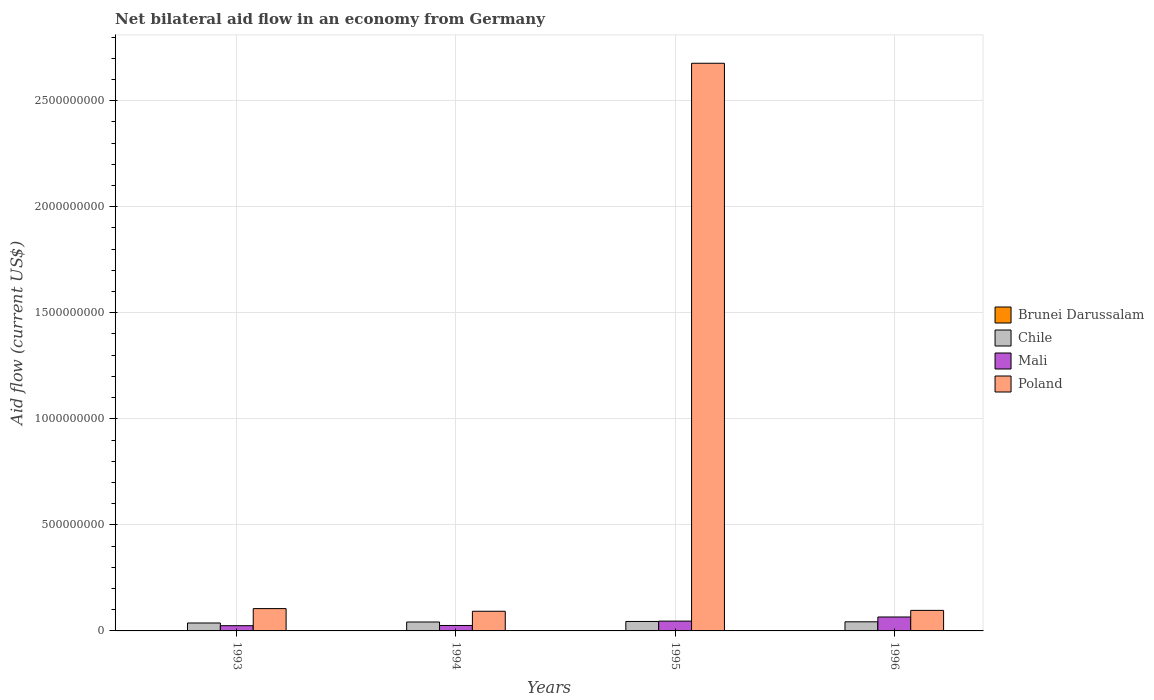How many different coloured bars are there?
Your answer should be compact. 4. How many bars are there on the 2nd tick from the left?
Provide a short and direct response. 4. What is the net bilateral aid flow in Mali in 1995?
Offer a terse response. 4.62e+07. Across all years, what is the maximum net bilateral aid flow in Chile?
Your answer should be very brief. 4.46e+07. Across all years, what is the minimum net bilateral aid flow in Chile?
Offer a terse response. 3.74e+07. What is the total net bilateral aid flow in Brunei Darussalam in the graph?
Make the answer very short. 9.00e+04. What is the difference between the net bilateral aid flow in Poland in 1994 and that in 1996?
Your answer should be very brief. -4.18e+06. What is the difference between the net bilateral aid flow in Poland in 1993 and the net bilateral aid flow in Chile in 1996?
Your answer should be compact. 6.23e+07. What is the average net bilateral aid flow in Mali per year?
Make the answer very short. 4.06e+07. In the year 1996, what is the difference between the net bilateral aid flow in Mali and net bilateral aid flow in Brunei Darussalam?
Make the answer very short. 6.57e+07. What is the ratio of the net bilateral aid flow in Chile in 1994 to that in 1995?
Keep it short and to the point. 0.94. Is the net bilateral aid flow in Poland in 1994 less than that in 1995?
Your answer should be compact. Yes. Is the difference between the net bilateral aid flow in Mali in 1993 and 1996 greater than the difference between the net bilateral aid flow in Brunei Darussalam in 1993 and 1996?
Give a very brief answer. No. What is the difference between the highest and the second highest net bilateral aid flow in Mali?
Give a very brief answer. 1.95e+07. What is the difference between the highest and the lowest net bilateral aid flow in Chile?
Your answer should be very brief. 7.19e+06. In how many years, is the net bilateral aid flow in Chile greater than the average net bilateral aid flow in Chile taken over all years?
Your answer should be compact. 3. Is it the case that in every year, the sum of the net bilateral aid flow in Brunei Darussalam and net bilateral aid flow in Poland is greater than the sum of net bilateral aid flow in Chile and net bilateral aid flow in Mali?
Make the answer very short. Yes. What does the 3rd bar from the left in 1996 represents?
Give a very brief answer. Mali. What does the 2nd bar from the right in 1995 represents?
Offer a terse response. Mali. Is it the case that in every year, the sum of the net bilateral aid flow in Poland and net bilateral aid flow in Mali is greater than the net bilateral aid flow in Brunei Darussalam?
Provide a succinct answer. Yes. Are all the bars in the graph horizontal?
Provide a short and direct response. No. What is the difference between two consecutive major ticks on the Y-axis?
Your response must be concise. 5.00e+08. How many legend labels are there?
Provide a short and direct response. 4. How are the legend labels stacked?
Provide a succinct answer. Vertical. What is the title of the graph?
Your answer should be very brief. Net bilateral aid flow in an economy from Germany. Does "Nicaragua" appear as one of the legend labels in the graph?
Your answer should be very brief. No. What is the label or title of the Y-axis?
Provide a short and direct response. Aid flow (current US$). What is the Aid flow (current US$) in Chile in 1993?
Provide a succinct answer. 3.74e+07. What is the Aid flow (current US$) in Mali in 1993?
Give a very brief answer. 2.46e+07. What is the Aid flow (current US$) in Poland in 1993?
Keep it short and to the point. 1.05e+08. What is the Aid flow (current US$) of Chile in 1994?
Make the answer very short. 4.21e+07. What is the Aid flow (current US$) in Mali in 1994?
Give a very brief answer. 2.57e+07. What is the Aid flow (current US$) in Poland in 1994?
Give a very brief answer. 9.27e+07. What is the Aid flow (current US$) of Brunei Darussalam in 1995?
Your answer should be very brief. 3.00e+04. What is the Aid flow (current US$) of Chile in 1995?
Offer a terse response. 4.46e+07. What is the Aid flow (current US$) of Mali in 1995?
Provide a short and direct response. 4.62e+07. What is the Aid flow (current US$) in Poland in 1995?
Give a very brief answer. 2.68e+09. What is the Aid flow (current US$) of Brunei Darussalam in 1996?
Your answer should be compact. 2.00e+04. What is the Aid flow (current US$) of Chile in 1996?
Ensure brevity in your answer.  4.30e+07. What is the Aid flow (current US$) of Mali in 1996?
Your answer should be compact. 6.57e+07. What is the Aid flow (current US$) of Poland in 1996?
Ensure brevity in your answer.  9.69e+07. Across all years, what is the maximum Aid flow (current US$) of Brunei Darussalam?
Keep it short and to the point. 3.00e+04. Across all years, what is the maximum Aid flow (current US$) of Chile?
Your answer should be very brief. 4.46e+07. Across all years, what is the maximum Aid flow (current US$) of Mali?
Give a very brief answer. 6.57e+07. Across all years, what is the maximum Aid flow (current US$) in Poland?
Give a very brief answer. 2.68e+09. Across all years, what is the minimum Aid flow (current US$) of Chile?
Offer a very short reply. 3.74e+07. Across all years, what is the minimum Aid flow (current US$) in Mali?
Give a very brief answer. 2.46e+07. Across all years, what is the minimum Aid flow (current US$) of Poland?
Offer a very short reply. 9.27e+07. What is the total Aid flow (current US$) of Brunei Darussalam in the graph?
Your response must be concise. 9.00e+04. What is the total Aid flow (current US$) in Chile in the graph?
Offer a terse response. 1.67e+08. What is the total Aid flow (current US$) in Mali in the graph?
Ensure brevity in your answer.  1.62e+08. What is the total Aid flow (current US$) of Poland in the graph?
Your answer should be very brief. 2.97e+09. What is the difference between the Aid flow (current US$) in Chile in 1993 and that in 1994?
Offer a terse response. -4.72e+06. What is the difference between the Aid flow (current US$) in Mali in 1993 and that in 1994?
Make the answer very short. -1.03e+06. What is the difference between the Aid flow (current US$) in Poland in 1993 and that in 1994?
Ensure brevity in your answer.  1.26e+07. What is the difference between the Aid flow (current US$) of Chile in 1993 and that in 1995?
Ensure brevity in your answer.  -7.19e+06. What is the difference between the Aid flow (current US$) of Mali in 1993 and that in 1995?
Your answer should be compact. -2.16e+07. What is the difference between the Aid flow (current US$) of Poland in 1993 and that in 1995?
Your answer should be very brief. -2.57e+09. What is the difference between the Aid flow (current US$) of Chile in 1993 and that in 1996?
Your answer should be compact. -5.55e+06. What is the difference between the Aid flow (current US$) in Mali in 1993 and that in 1996?
Give a very brief answer. -4.10e+07. What is the difference between the Aid flow (current US$) in Poland in 1993 and that in 1996?
Provide a short and direct response. 8.39e+06. What is the difference between the Aid flow (current US$) of Chile in 1994 and that in 1995?
Provide a succinct answer. -2.47e+06. What is the difference between the Aid flow (current US$) of Mali in 1994 and that in 1995?
Offer a terse response. -2.05e+07. What is the difference between the Aid flow (current US$) in Poland in 1994 and that in 1995?
Offer a very short reply. -2.58e+09. What is the difference between the Aid flow (current US$) of Brunei Darussalam in 1994 and that in 1996?
Provide a short and direct response. 0. What is the difference between the Aid flow (current US$) of Chile in 1994 and that in 1996?
Ensure brevity in your answer.  -8.30e+05. What is the difference between the Aid flow (current US$) in Mali in 1994 and that in 1996?
Offer a terse response. -4.00e+07. What is the difference between the Aid flow (current US$) of Poland in 1994 and that in 1996?
Offer a very short reply. -4.18e+06. What is the difference between the Aid flow (current US$) in Chile in 1995 and that in 1996?
Offer a very short reply. 1.64e+06. What is the difference between the Aid flow (current US$) in Mali in 1995 and that in 1996?
Offer a very short reply. -1.95e+07. What is the difference between the Aid flow (current US$) of Poland in 1995 and that in 1996?
Your answer should be very brief. 2.58e+09. What is the difference between the Aid flow (current US$) in Brunei Darussalam in 1993 and the Aid flow (current US$) in Chile in 1994?
Ensure brevity in your answer.  -4.21e+07. What is the difference between the Aid flow (current US$) of Brunei Darussalam in 1993 and the Aid flow (current US$) of Mali in 1994?
Your answer should be very brief. -2.57e+07. What is the difference between the Aid flow (current US$) of Brunei Darussalam in 1993 and the Aid flow (current US$) of Poland in 1994?
Provide a short and direct response. -9.27e+07. What is the difference between the Aid flow (current US$) in Chile in 1993 and the Aid flow (current US$) in Mali in 1994?
Give a very brief answer. 1.17e+07. What is the difference between the Aid flow (current US$) of Chile in 1993 and the Aid flow (current US$) of Poland in 1994?
Provide a succinct answer. -5.53e+07. What is the difference between the Aid flow (current US$) of Mali in 1993 and the Aid flow (current US$) of Poland in 1994?
Make the answer very short. -6.80e+07. What is the difference between the Aid flow (current US$) of Brunei Darussalam in 1993 and the Aid flow (current US$) of Chile in 1995?
Ensure brevity in your answer.  -4.46e+07. What is the difference between the Aid flow (current US$) in Brunei Darussalam in 1993 and the Aid flow (current US$) in Mali in 1995?
Ensure brevity in your answer.  -4.62e+07. What is the difference between the Aid flow (current US$) in Brunei Darussalam in 1993 and the Aid flow (current US$) in Poland in 1995?
Keep it short and to the point. -2.68e+09. What is the difference between the Aid flow (current US$) in Chile in 1993 and the Aid flow (current US$) in Mali in 1995?
Offer a very short reply. -8.79e+06. What is the difference between the Aid flow (current US$) in Chile in 1993 and the Aid flow (current US$) in Poland in 1995?
Make the answer very short. -2.64e+09. What is the difference between the Aid flow (current US$) in Mali in 1993 and the Aid flow (current US$) in Poland in 1995?
Give a very brief answer. -2.65e+09. What is the difference between the Aid flow (current US$) of Brunei Darussalam in 1993 and the Aid flow (current US$) of Chile in 1996?
Ensure brevity in your answer.  -4.29e+07. What is the difference between the Aid flow (current US$) in Brunei Darussalam in 1993 and the Aid flow (current US$) in Mali in 1996?
Keep it short and to the point. -6.57e+07. What is the difference between the Aid flow (current US$) in Brunei Darussalam in 1993 and the Aid flow (current US$) in Poland in 1996?
Ensure brevity in your answer.  -9.68e+07. What is the difference between the Aid flow (current US$) of Chile in 1993 and the Aid flow (current US$) of Mali in 1996?
Your response must be concise. -2.83e+07. What is the difference between the Aid flow (current US$) of Chile in 1993 and the Aid flow (current US$) of Poland in 1996?
Keep it short and to the point. -5.94e+07. What is the difference between the Aid flow (current US$) of Mali in 1993 and the Aid flow (current US$) of Poland in 1996?
Your answer should be very brief. -7.22e+07. What is the difference between the Aid flow (current US$) of Brunei Darussalam in 1994 and the Aid flow (current US$) of Chile in 1995?
Your answer should be very brief. -4.46e+07. What is the difference between the Aid flow (current US$) of Brunei Darussalam in 1994 and the Aid flow (current US$) of Mali in 1995?
Make the answer very short. -4.62e+07. What is the difference between the Aid flow (current US$) in Brunei Darussalam in 1994 and the Aid flow (current US$) in Poland in 1995?
Ensure brevity in your answer.  -2.68e+09. What is the difference between the Aid flow (current US$) of Chile in 1994 and the Aid flow (current US$) of Mali in 1995?
Ensure brevity in your answer.  -4.07e+06. What is the difference between the Aid flow (current US$) in Chile in 1994 and the Aid flow (current US$) in Poland in 1995?
Provide a succinct answer. -2.63e+09. What is the difference between the Aid flow (current US$) of Mali in 1994 and the Aid flow (current US$) of Poland in 1995?
Make the answer very short. -2.65e+09. What is the difference between the Aid flow (current US$) of Brunei Darussalam in 1994 and the Aid flow (current US$) of Chile in 1996?
Your response must be concise. -4.29e+07. What is the difference between the Aid flow (current US$) of Brunei Darussalam in 1994 and the Aid flow (current US$) of Mali in 1996?
Keep it short and to the point. -6.57e+07. What is the difference between the Aid flow (current US$) in Brunei Darussalam in 1994 and the Aid flow (current US$) in Poland in 1996?
Ensure brevity in your answer.  -9.68e+07. What is the difference between the Aid flow (current US$) in Chile in 1994 and the Aid flow (current US$) in Mali in 1996?
Offer a very short reply. -2.36e+07. What is the difference between the Aid flow (current US$) of Chile in 1994 and the Aid flow (current US$) of Poland in 1996?
Your answer should be very brief. -5.47e+07. What is the difference between the Aid flow (current US$) of Mali in 1994 and the Aid flow (current US$) of Poland in 1996?
Your response must be concise. -7.12e+07. What is the difference between the Aid flow (current US$) in Brunei Darussalam in 1995 and the Aid flow (current US$) in Chile in 1996?
Provide a short and direct response. -4.29e+07. What is the difference between the Aid flow (current US$) of Brunei Darussalam in 1995 and the Aid flow (current US$) of Mali in 1996?
Offer a very short reply. -6.57e+07. What is the difference between the Aid flow (current US$) of Brunei Darussalam in 1995 and the Aid flow (current US$) of Poland in 1996?
Keep it short and to the point. -9.68e+07. What is the difference between the Aid flow (current US$) in Chile in 1995 and the Aid flow (current US$) in Mali in 1996?
Ensure brevity in your answer.  -2.11e+07. What is the difference between the Aid flow (current US$) of Chile in 1995 and the Aid flow (current US$) of Poland in 1996?
Ensure brevity in your answer.  -5.23e+07. What is the difference between the Aid flow (current US$) of Mali in 1995 and the Aid flow (current US$) of Poland in 1996?
Give a very brief answer. -5.07e+07. What is the average Aid flow (current US$) of Brunei Darussalam per year?
Provide a succinct answer. 2.25e+04. What is the average Aid flow (current US$) in Chile per year?
Offer a terse response. 4.18e+07. What is the average Aid flow (current US$) of Mali per year?
Offer a very short reply. 4.06e+07. What is the average Aid flow (current US$) of Poland per year?
Make the answer very short. 7.43e+08. In the year 1993, what is the difference between the Aid flow (current US$) of Brunei Darussalam and Aid flow (current US$) of Chile?
Keep it short and to the point. -3.74e+07. In the year 1993, what is the difference between the Aid flow (current US$) of Brunei Darussalam and Aid flow (current US$) of Mali?
Offer a very short reply. -2.46e+07. In the year 1993, what is the difference between the Aid flow (current US$) of Brunei Darussalam and Aid flow (current US$) of Poland?
Your answer should be compact. -1.05e+08. In the year 1993, what is the difference between the Aid flow (current US$) in Chile and Aid flow (current US$) in Mali?
Offer a terse response. 1.28e+07. In the year 1993, what is the difference between the Aid flow (current US$) in Chile and Aid flow (current US$) in Poland?
Your answer should be very brief. -6.78e+07. In the year 1993, what is the difference between the Aid flow (current US$) in Mali and Aid flow (current US$) in Poland?
Provide a succinct answer. -8.06e+07. In the year 1994, what is the difference between the Aid flow (current US$) in Brunei Darussalam and Aid flow (current US$) in Chile?
Ensure brevity in your answer.  -4.21e+07. In the year 1994, what is the difference between the Aid flow (current US$) in Brunei Darussalam and Aid flow (current US$) in Mali?
Offer a very short reply. -2.57e+07. In the year 1994, what is the difference between the Aid flow (current US$) of Brunei Darussalam and Aid flow (current US$) of Poland?
Make the answer very short. -9.27e+07. In the year 1994, what is the difference between the Aid flow (current US$) in Chile and Aid flow (current US$) in Mali?
Your response must be concise. 1.64e+07. In the year 1994, what is the difference between the Aid flow (current US$) of Chile and Aid flow (current US$) of Poland?
Ensure brevity in your answer.  -5.06e+07. In the year 1994, what is the difference between the Aid flow (current US$) of Mali and Aid flow (current US$) of Poland?
Make the answer very short. -6.70e+07. In the year 1995, what is the difference between the Aid flow (current US$) in Brunei Darussalam and Aid flow (current US$) in Chile?
Your answer should be compact. -4.46e+07. In the year 1995, what is the difference between the Aid flow (current US$) of Brunei Darussalam and Aid flow (current US$) of Mali?
Your answer should be very brief. -4.62e+07. In the year 1995, what is the difference between the Aid flow (current US$) of Brunei Darussalam and Aid flow (current US$) of Poland?
Keep it short and to the point. -2.68e+09. In the year 1995, what is the difference between the Aid flow (current US$) of Chile and Aid flow (current US$) of Mali?
Keep it short and to the point. -1.60e+06. In the year 1995, what is the difference between the Aid flow (current US$) of Chile and Aid flow (current US$) of Poland?
Offer a terse response. -2.63e+09. In the year 1995, what is the difference between the Aid flow (current US$) of Mali and Aid flow (current US$) of Poland?
Your response must be concise. -2.63e+09. In the year 1996, what is the difference between the Aid flow (current US$) of Brunei Darussalam and Aid flow (current US$) of Chile?
Offer a terse response. -4.29e+07. In the year 1996, what is the difference between the Aid flow (current US$) in Brunei Darussalam and Aid flow (current US$) in Mali?
Your answer should be very brief. -6.57e+07. In the year 1996, what is the difference between the Aid flow (current US$) in Brunei Darussalam and Aid flow (current US$) in Poland?
Your answer should be compact. -9.68e+07. In the year 1996, what is the difference between the Aid flow (current US$) of Chile and Aid flow (current US$) of Mali?
Keep it short and to the point. -2.27e+07. In the year 1996, what is the difference between the Aid flow (current US$) of Chile and Aid flow (current US$) of Poland?
Make the answer very short. -5.39e+07. In the year 1996, what is the difference between the Aid flow (current US$) in Mali and Aid flow (current US$) in Poland?
Offer a very short reply. -3.12e+07. What is the ratio of the Aid flow (current US$) in Chile in 1993 to that in 1994?
Ensure brevity in your answer.  0.89. What is the ratio of the Aid flow (current US$) in Mali in 1993 to that in 1994?
Ensure brevity in your answer.  0.96. What is the ratio of the Aid flow (current US$) of Poland in 1993 to that in 1994?
Keep it short and to the point. 1.14. What is the ratio of the Aid flow (current US$) of Brunei Darussalam in 1993 to that in 1995?
Ensure brevity in your answer.  0.67. What is the ratio of the Aid flow (current US$) in Chile in 1993 to that in 1995?
Offer a terse response. 0.84. What is the ratio of the Aid flow (current US$) in Mali in 1993 to that in 1995?
Your response must be concise. 0.53. What is the ratio of the Aid flow (current US$) in Poland in 1993 to that in 1995?
Provide a succinct answer. 0.04. What is the ratio of the Aid flow (current US$) in Chile in 1993 to that in 1996?
Your answer should be very brief. 0.87. What is the ratio of the Aid flow (current US$) of Mali in 1993 to that in 1996?
Make the answer very short. 0.38. What is the ratio of the Aid flow (current US$) of Poland in 1993 to that in 1996?
Ensure brevity in your answer.  1.09. What is the ratio of the Aid flow (current US$) in Chile in 1994 to that in 1995?
Offer a terse response. 0.94. What is the ratio of the Aid flow (current US$) of Mali in 1994 to that in 1995?
Your answer should be very brief. 0.56. What is the ratio of the Aid flow (current US$) of Poland in 1994 to that in 1995?
Your answer should be compact. 0.03. What is the ratio of the Aid flow (current US$) of Brunei Darussalam in 1994 to that in 1996?
Your answer should be compact. 1. What is the ratio of the Aid flow (current US$) of Chile in 1994 to that in 1996?
Provide a succinct answer. 0.98. What is the ratio of the Aid flow (current US$) of Mali in 1994 to that in 1996?
Give a very brief answer. 0.39. What is the ratio of the Aid flow (current US$) in Poland in 1994 to that in 1996?
Your answer should be compact. 0.96. What is the ratio of the Aid flow (current US$) of Chile in 1995 to that in 1996?
Provide a short and direct response. 1.04. What is the ratio of the Aid flow (current US$) in Mali in 1995 to that in 1996?
Give a very brief answer. 0.7. What is the ratio of the Aid flow (current US$) of Poland in 1995 to that in 1996?
Make the answer very short. 27.63. What is the difference between the highest and the second highest Aid flow (current US$) of Chile?
Your answer should be compact. 1.64e+06. What is the difference between the highest and the second highest Aid flow (current US$) of Mali?
Ensure brevity in your answer.  1.95e+07. What is the difference between the highest and the second highest Aid flow (current US$) of Poland?
Keep it short and to the point. 2.57e+09. What is the difference between the highest and the lowest Aid flow (current US$) in Brunei Darussalam?
Keep it short and to the point. 10000. What is the difference between the highest and the lowest Aid flow (current US$) in Chile?
Provide a short and direct response. 7.19e+06. What is the difference between the highest and the lowest Aid flow (current US$) of Mali?
Provide a succinct answer. 4.10e+07. What is the difference between the highest and the lowest Aid flow (current US$) in Poland?
Make the answer very short. 2.58e+09. 